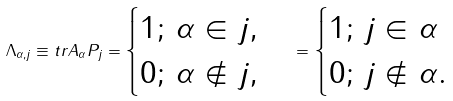<formula> <loc_0><loc_0><loc_500><loc_500>\Lambda _ { \alpha , j } \equiv t r A _ { \alpha } P _ { j } = \begin{cases} 1 ; \, \alpha \in j , \\ 0 ; \, \alpha \notin j , \end{cases} = \begin{cases} 1 ; \, j \in \alpha \\ 0 ; \, j \notin \alpha . \end{cases}</formula> 